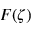Convert formula to latex. <formula><loc_0><loc_0><loc_500><loc_500>F ( \zeta )</formula> 